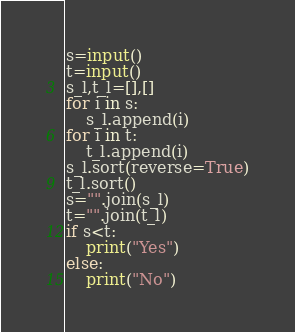<code> <loc_0><loc_0><loc_500><loc_500><_Python_>s=input()
t=input()
s_l,t_l=[],[]
for i in s:
	s_l.append(i)
for i in t:
	t_l.append(i)
s_l.sort(reverse=True)
t_l.sort()
s="".join(s_l)
t="".join(t_l)
if s<t:
	print("Yes")
else:
	print("No")
</code> 